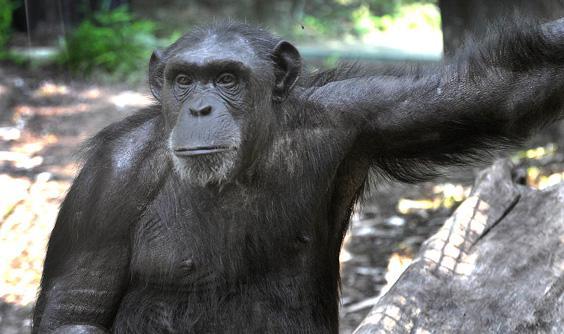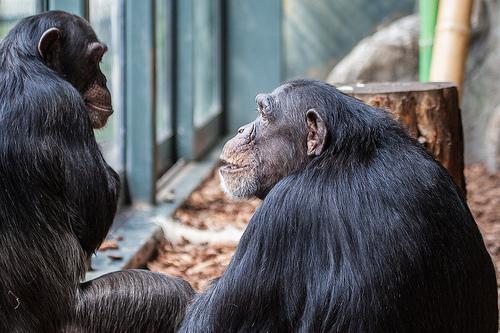The first image is the image on the left, the second image is the image on the right. Analyze the images presented: Is the assertion "The image on the right contains a baby and its mother." valid? Answer yes or no. No. The first image is the image on the left, the second image is the image on the right. Analyze the images presented: Is the assertion "The right image shows a chimp with an animal on its back." valid? Answer yes or no. No. 